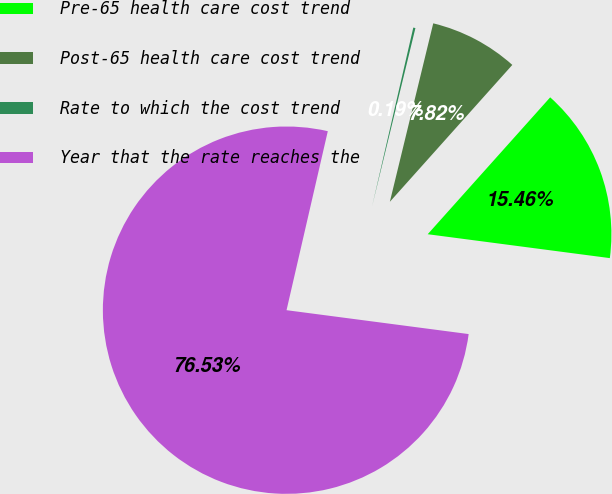Convert chart. <chart><loc_0><loc_0><loc_500><loc_500><pie_chart><fcel>Pre-65 health care cost trend<fcel>Post-65 health care cost trend<fcel>Rate to which the cost trend<fcel>Year that the rate reaches the<nl><fcel>15.46%<fcel>7.82%<fcel>0.19%<fcel>76.53%<nl></chart> 